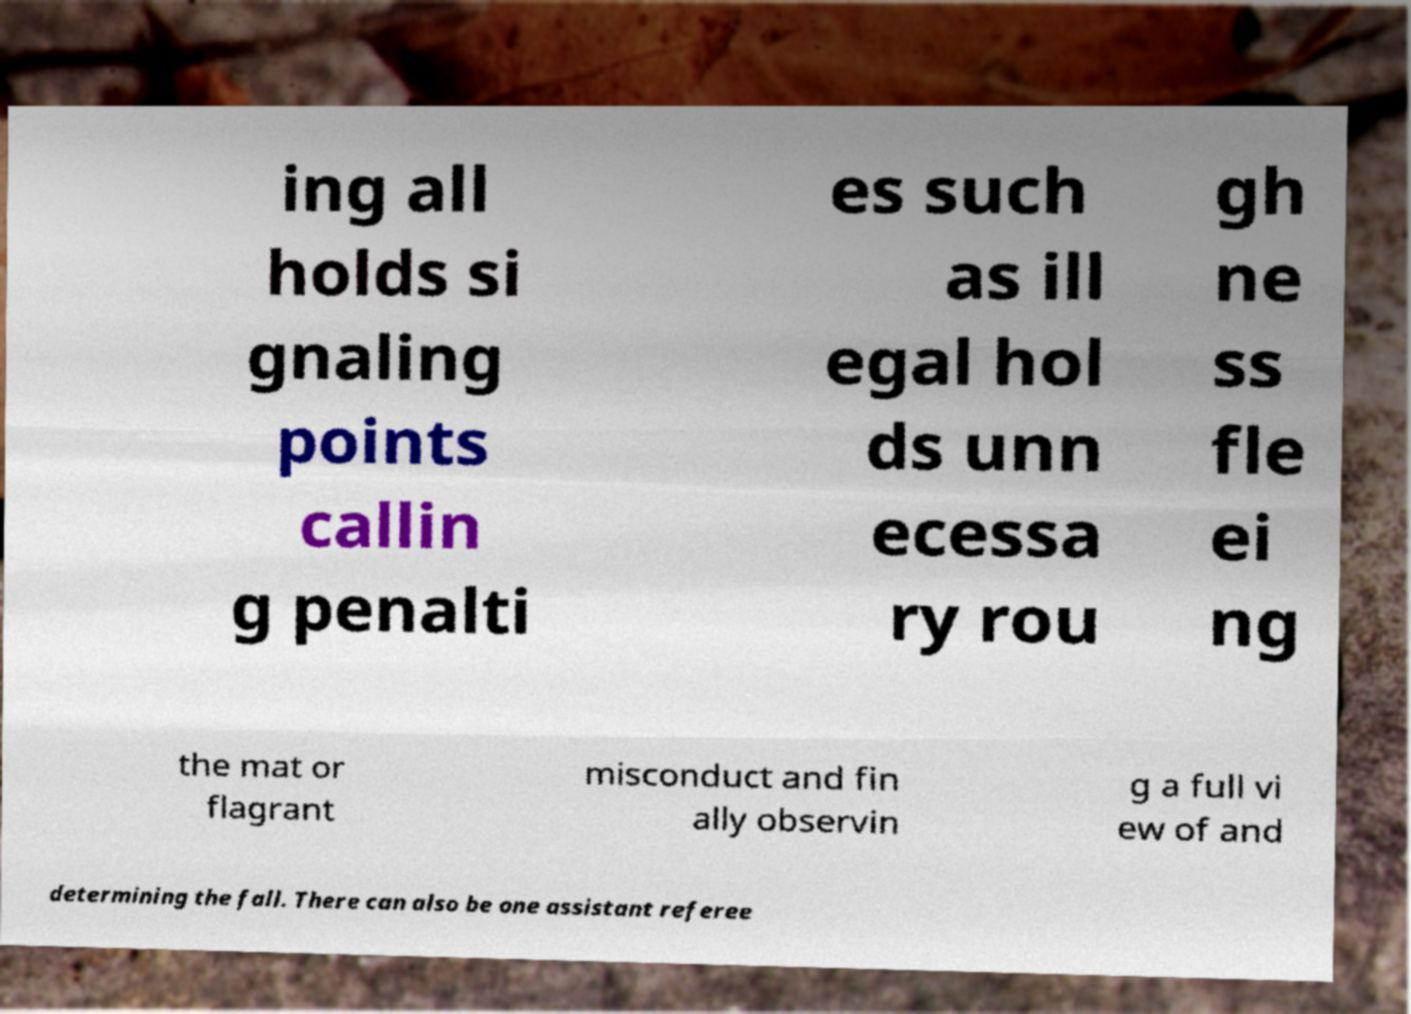Please identify and transcribe the text found in this image. ing all holds si gnaling points callin g penalti es such as ill egal hol ds unn ecessa ry rou gh ne ss fle ei ng the mat or flagrant misconduct and fin ally observin g a full vi ew of and determining the fall. There can also be one assistant referee 